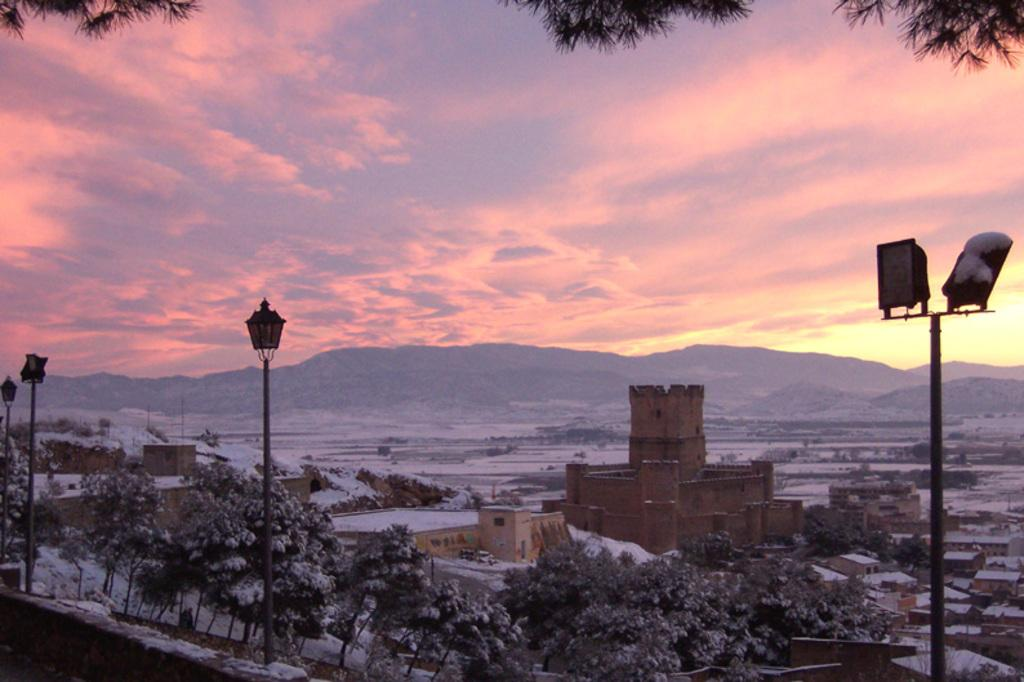What time of day is depicted in the image? The image depicts a sunset. What type of structures can be seen in the image? There are many houses in the image. What type of vegetation is present in the image? Trees are present in the image. What type of lighting is visible in the image? There are lampposts in the image. What type of competition is taking place in the image? There is no competition present in the image; it depicts a sunset with houses, trees, and lampposts. How does the fly navigate during the sunset in the image? There are no flies present in the image; it depicts a sunset with houses, trees, and lampposts. 